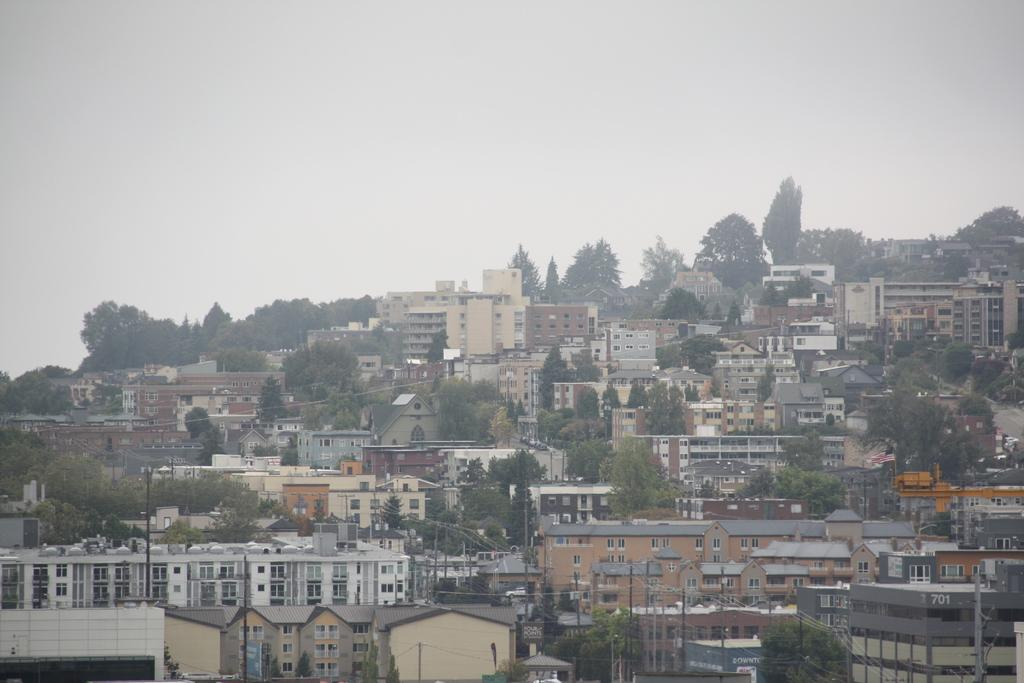What type of structures can be seen in the image? There are many buildings in the image. What other objects can be seen in the image besides buildings? There are trees, poles, and wires in the image. What is visible in the background of the image? The sky is visible in the background of the image. What type of plate is being used to serve the industry in the image? There is no plate or industry present in the image. 